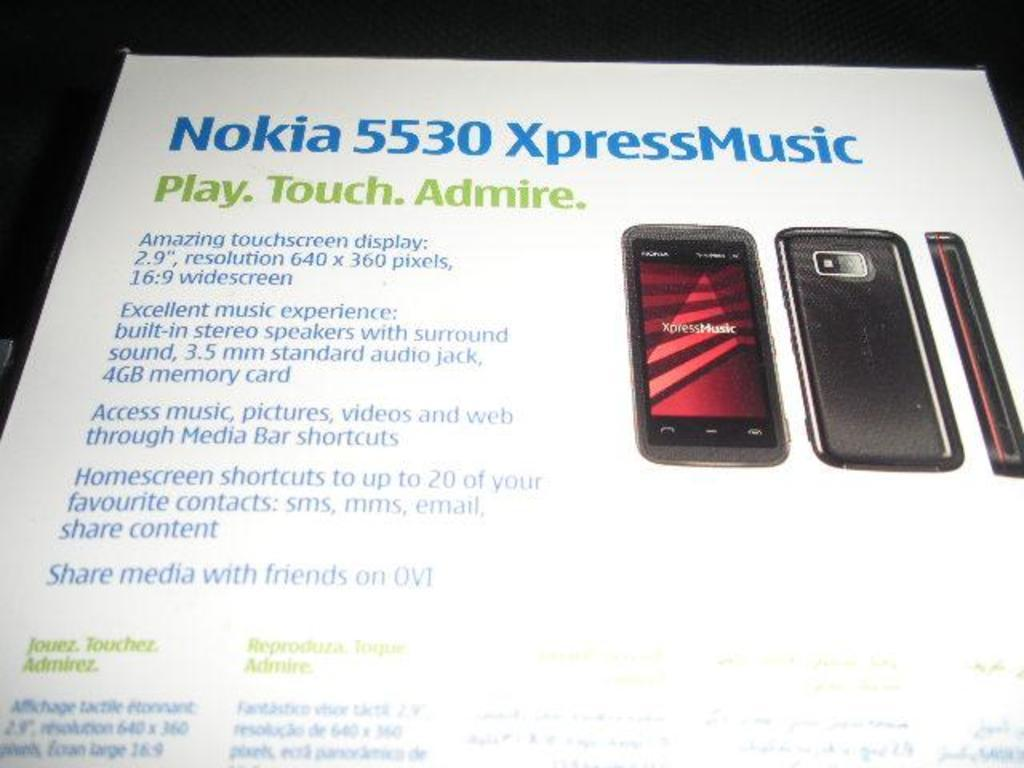<image>
Write a terse but informative summary of the picture. A Pumphelet of Nokia 5530 Xpress Music brand shows details. 